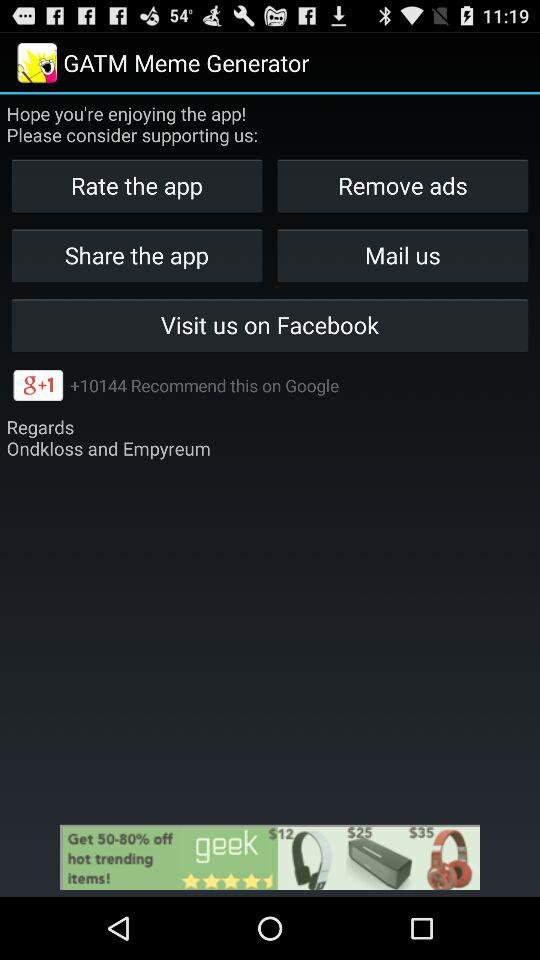What was this application rated?
When the provided information is insufficient, respond with <no answer>. <no answer> 